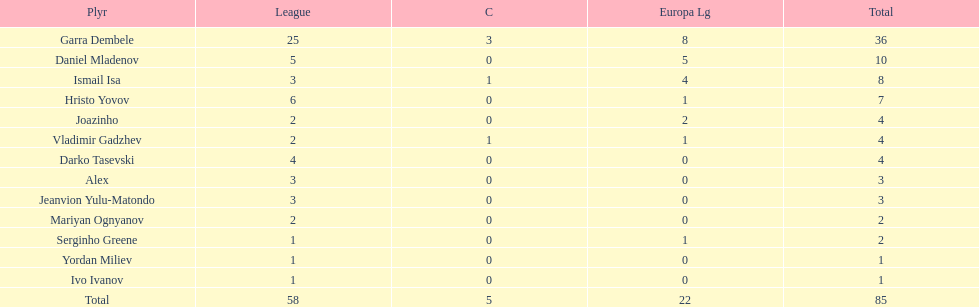Who was the top goalscorer on this team? Garra Dembele. 